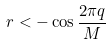<formula> <loc_0><loc_0><loc_500><loc_500>r < - \cos \frac { 2 \pi q } { M }</formula> 